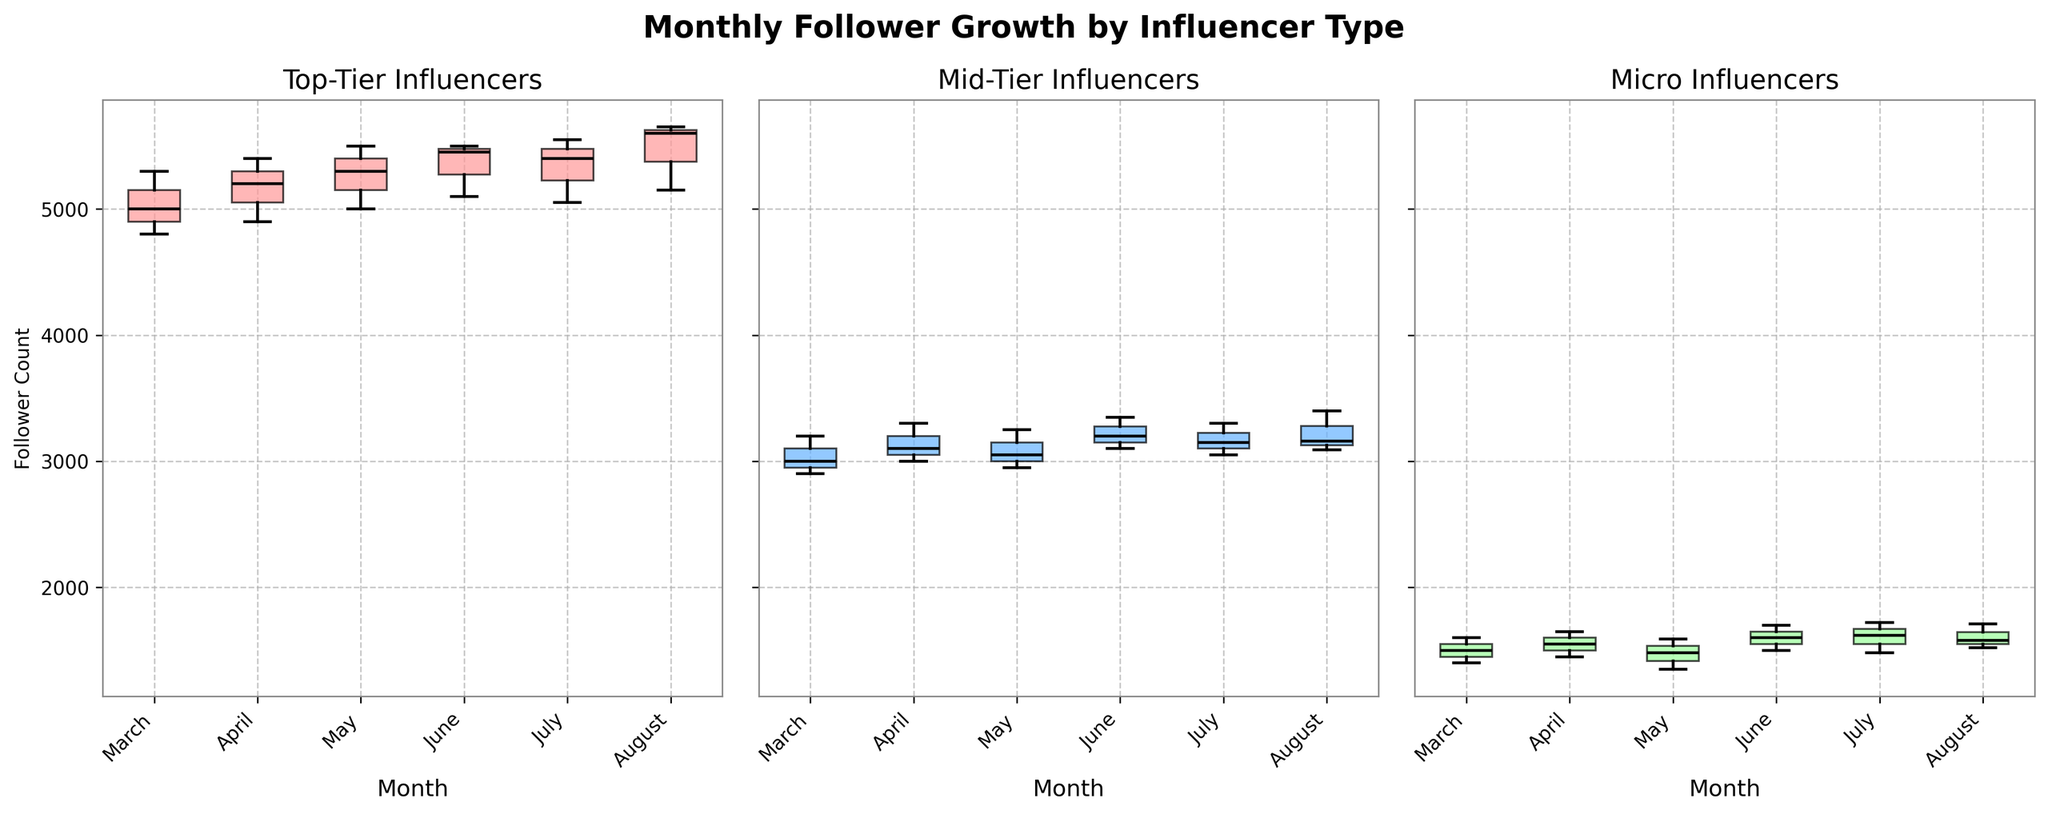What's the title of the figure? The title of the figure is located at the top, centered and in bold. It reads "Monthly Follower Growth by Influencer Type".
Answer: Monthly Follower Growth by Influencer Type What does the x-axis represent in each subplot? The x-axis in each subplot represents the months from March to August.
Answer: Months What color are the box plots for Mid-Tier influencers? The box plots for the Mid-Tier influencers are colored in a light blue shade.
Answer: Light blue Which influencer type has the highest median follower count in March? By inspecting the medians of the box plots for March in each subplot, the Top-Tier influencers have the highest median.
Answer: Top-Tier What is the trend in follower counts for Micro influencers from March to August? Observing the median lines of the box plots for Micro influencers from March to August, the trend generally shows an increase in follower counts.
Answer: Increasing Which month shows the most variability in the follower count for Mid-Tier influencers? The month with the largest interquartile range (IQR) indicates the most variability. For Mid-Tier influencers, June has the widest box, suggesting the highest variability.
Answer: June Compare the variability between Top-Tier and Mid-Tier influencers for June. Which group shows more variability? The variability is indicated by the size of the boxes and the length of the whiskers. In June, the Mid-Tier influencers show a wider box with longer whiskers compared to Top-Tier influencers, indicating more variability.
Answer: Mid-Tier How does the median follower count of Top-Tier influencers in July compare to June? By comparing the median lines in the box plots for July and June, the median for Top-Tier influencers in July is slightly lower than in June.
Answer: Lower For which influencer type does August have the highest follower count spread? The spread is indicated by the range from the lowest to the highest whisker. In August, Top-Tier influencers have the highest spread, with a wider range of follower counts visible in the box plot.
Answer: Top-Tier What is the median follower count for Micro influencers in May? The median is the line inside the box. For Micro influencers in May, the median lies approximately at 1480 followers.
Answer: 1480 